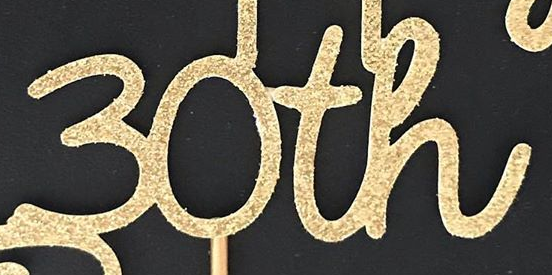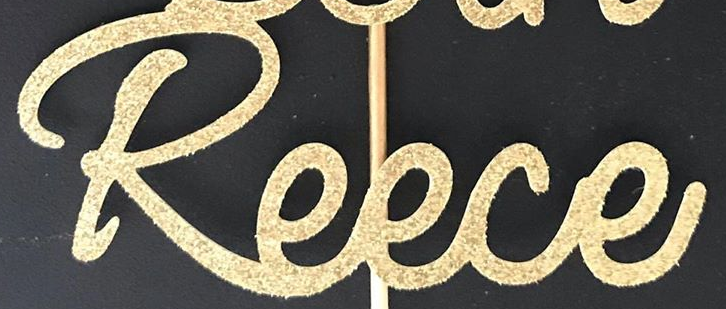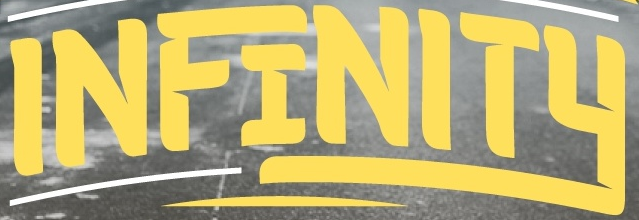What text is displayed in these images sequentially, separated by a semicolon? 30th; Reece; INFINITY 